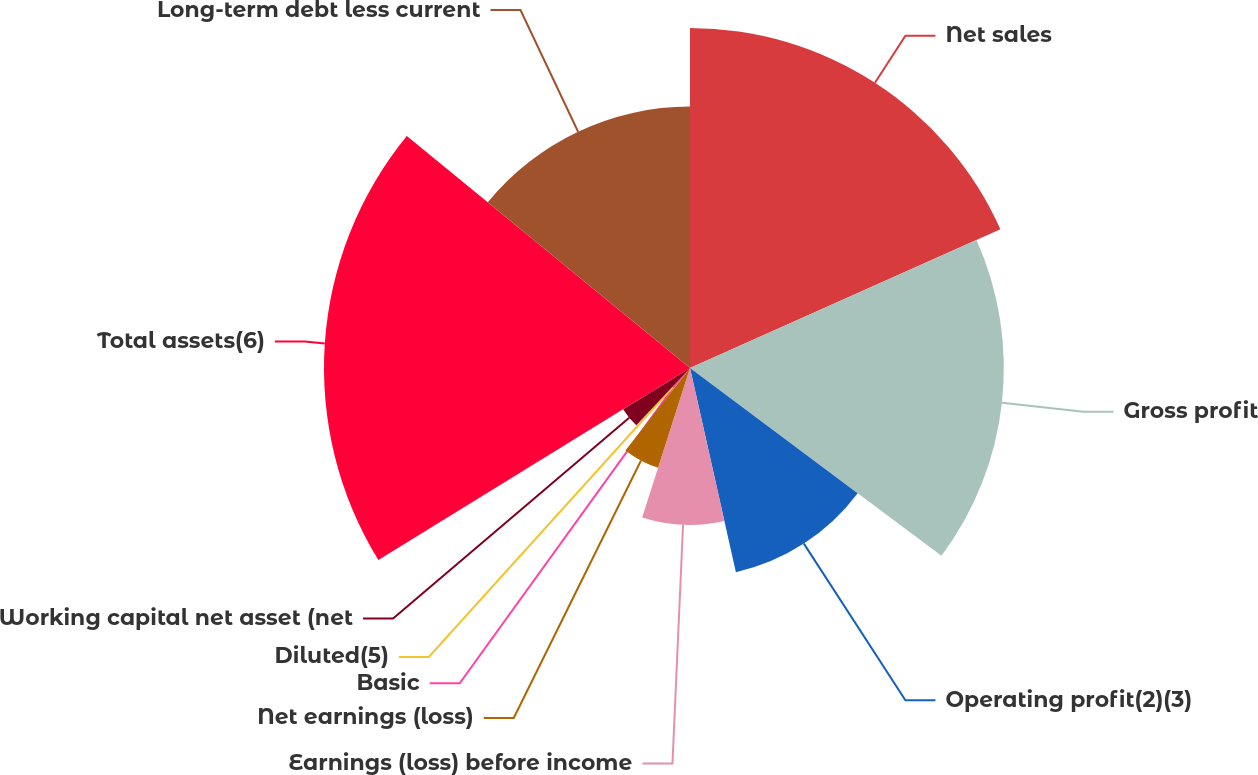Convert chart. <chart><loc_0><loc_0><loc_500><loc_500><pie_chart><fcel>Net sales<fcel>Gross profit<fcel>Operating profit(2)(3)<fcel>Earnings (loss) before income<fcel>Net earnings (loss)<fcel>Basic<fcel>Diluted(5)<fcel>Working capital net asset (net<fcel>Total assets(6)<fcel>Long-term debt less current<nl><fcel>18.31%<fcel>16.9%<fcel>11.27%<fcel>8.45%<fcel>5.64%<fcel>1.41%<fcel>0.0%<fcel>4.23%<fcel>19.71%<fcel>14.08%<nl></chart> 